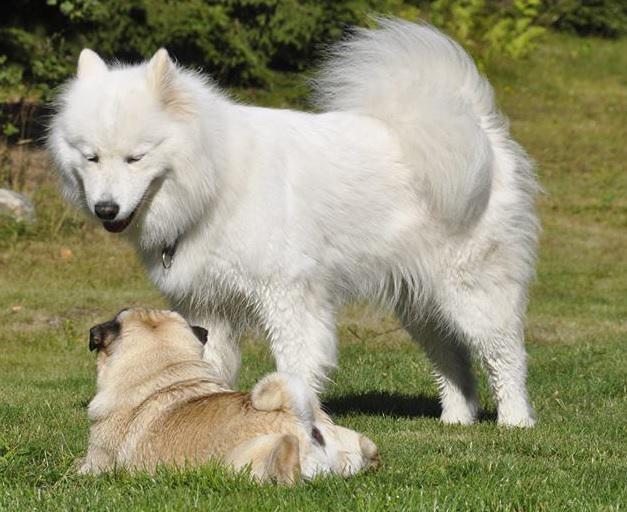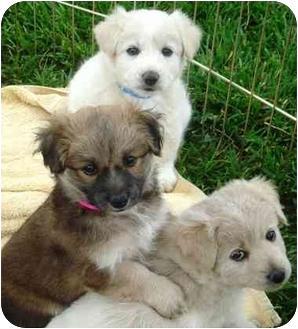The first image is the image on the left, the second image is the image on the right. For the images displayed, is the sentence "There is a flowering plant behind one of the dogs." factually correct? Answer yes or no. No. The first image is the image on the left, the second image is the image on the right. Considering the images on both sides, is "One white dog is shown with flowers in the background in one image." valid? Answer yes or no. No. 